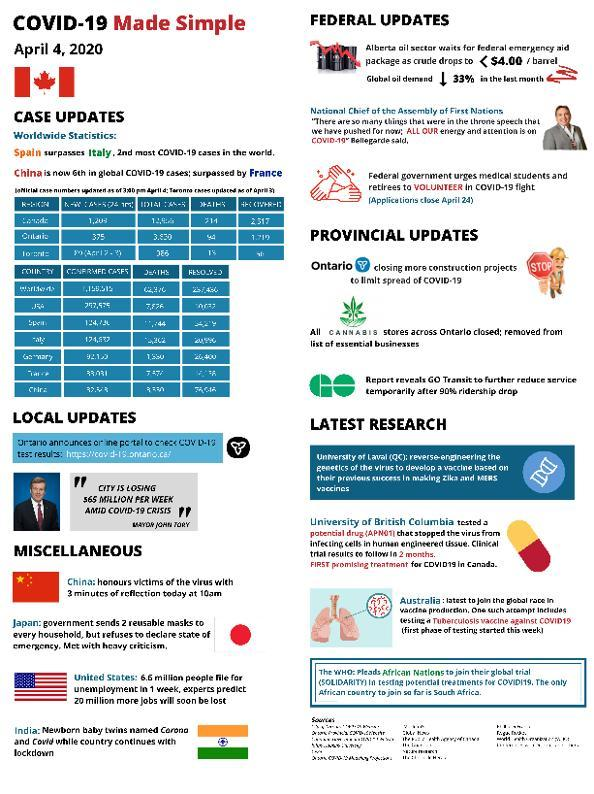As per worldwide statistics of Covid-19 as on April 4, 2020, which country has the most recorded Covid cases?
Answer the question with a short phrase. Spain As per worldwide statistics of Covid-19 as on April 4, 2020, which country has the second most recorded Covid cases? Italy 